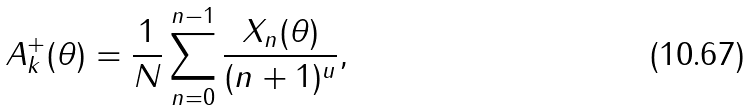Convert formula to latex. <formula><loc_0><loc_0><loc_500><loc_500>A ^ { + } _ { k } ( \theta ) = \frac { 1 } { N } \sum _ { n = 0 } ^ { n - 1 } \frac { X _ { n } ( \theta ) } { ( n + 1 ) ^ { u } } ,</formula> 